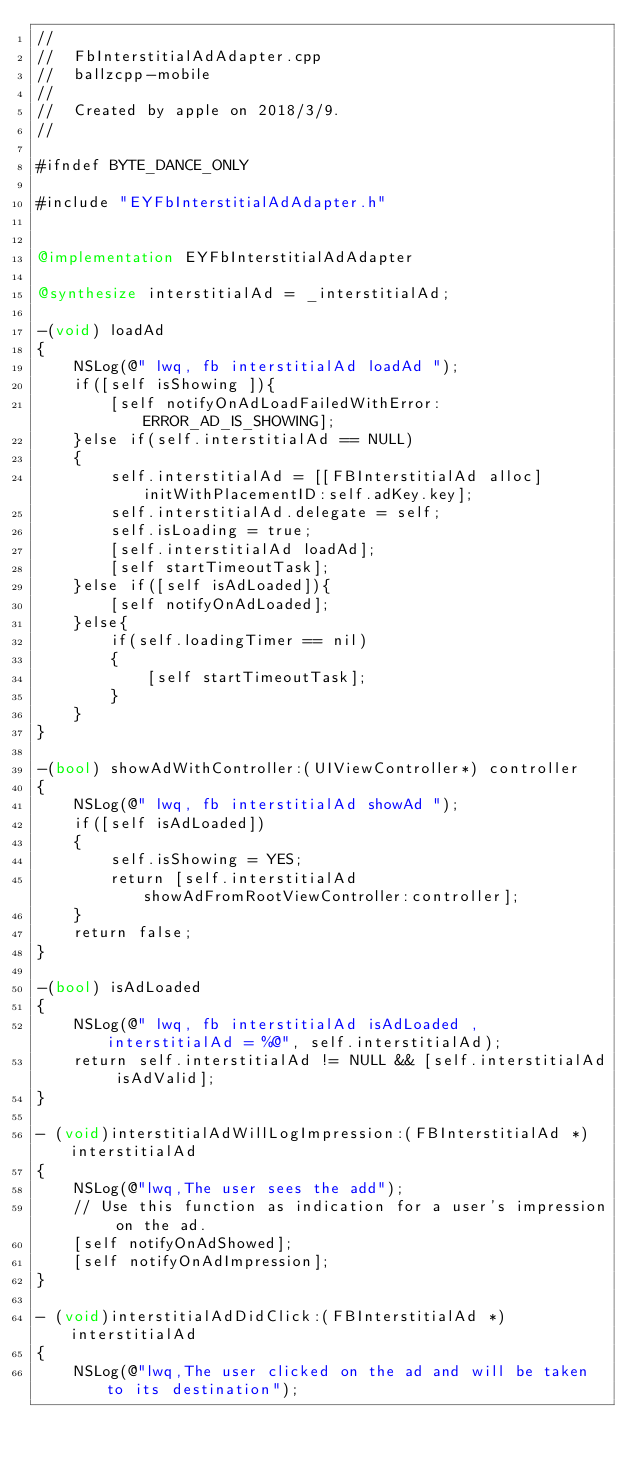Convert code to text. <code><loc_0><loc_0><loc_500><loc_500><_ObjectiveC_>//
//  FbInterstitialAdAdapter.cpp
//  ballzcpp-mobile
//
//  Created by apple on 2018/3/9.
//

#ifndef BYTE_DANCE_ONLY

#include "EYFbInterstitialAdAdapter.h"


@implementation EYFbInterstitialAdAdapter

@synthesize interstitialAd = _interstitialAd;

-(void) loadAd
{
    NSLog(@" lwq, fb interstitialAd loadAd ");
    if([self isShowing ]){
        [self notifyOnAdLoadFailedWithError:ERROR_AD_IS_SHOWING];
    }else if(self.interstitialAd == NULL)
    {
        self.interstitialAd = [[FBInterstitialAd alloc] initWithPlacementID:self.adKey.key];
        self.interstitialAd.delegate = self;
        self.isLoading = true;
        [self.interstitialAd loadAd];
        [self startTimeoutTask];
    }else if([self isAdLoaded]){
        [self notifyOnAdLoaded];
    }else{
        if(self.loadingTimer == nil)
        {
            [self startTimeoutTask];
        }
    }
}

-(bool) showAdWithController:(UIViewController*) controller
{
    NSLog(@" lwq, fb interstitialAd showAd ");
    if([self isAdLoaded])
    {
        self.isShowing = YES;
        return [self.interstitialAd showAdFromRootViewController:controller];
    }
    return false;
}

-(bool) isAdLoaded
{
    NSLog(@" lwq, fb interstitialAd isAdLoaded , interstitialAd = %@", self.interstitialAd);
    return self.interstitialAd != NULL && [self.interstitialAd isAdValid];
}

- (void)interstitialAdWillLogImpression:(FBInterstitialAd *)interstitialAd
{
    NSLog(@"lwq,The user sees the add");
    // Use this function as indication for a user's impression on the ad.
    [self notifyOnAdShowed];
    [self notifyOnAdImpression];
}

- (void)interstitialAdDidClick:(FBInterstitialAd *)interstitialAd
{
    NSLog(@"lwq,The user clicked on the ad and will be taken to its destination");</code> 